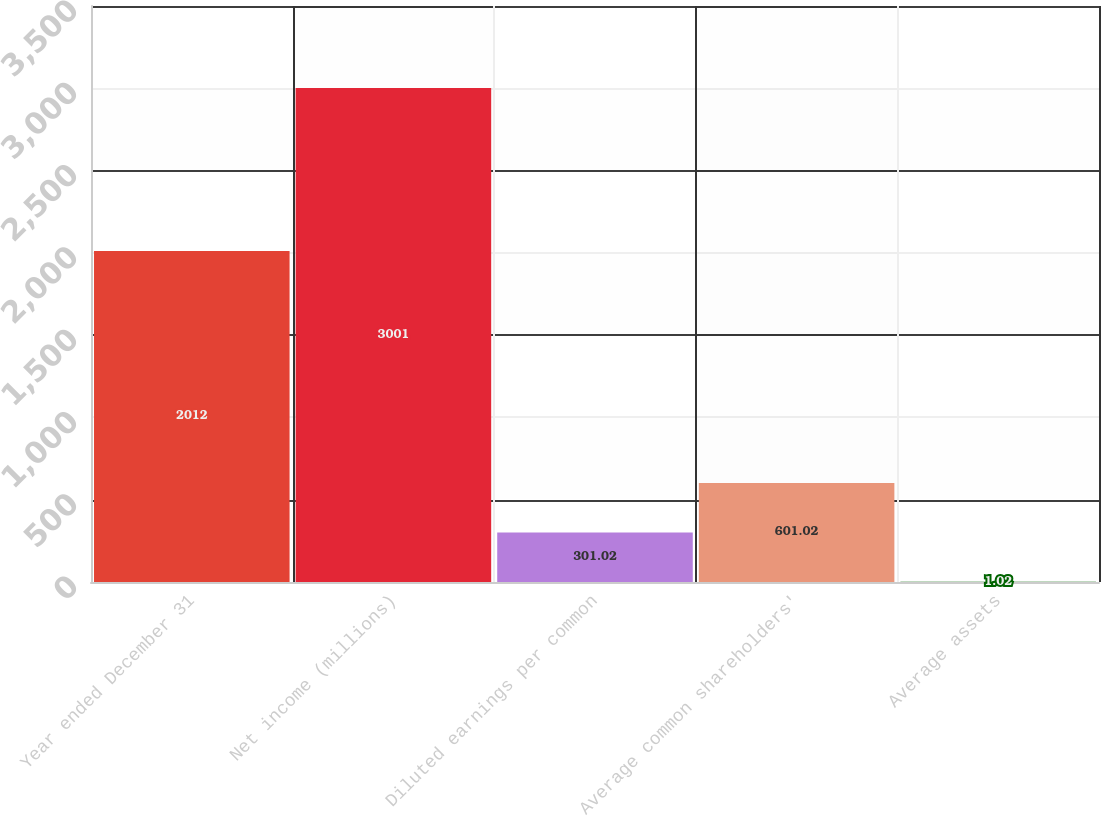<chart> <loc_0><loc_0><loc_500><loc_500><bar_chart><fcel>Year ended December 31<fcel>Net income (millions)<fcel>Diluted earnings per common<fcel>Average common shareholders'<fcel>Average assets<nl><fcel>2012<fcel>3001<fcel>301.02<fcel>601.02<fcel>1.02<nl></chart> 